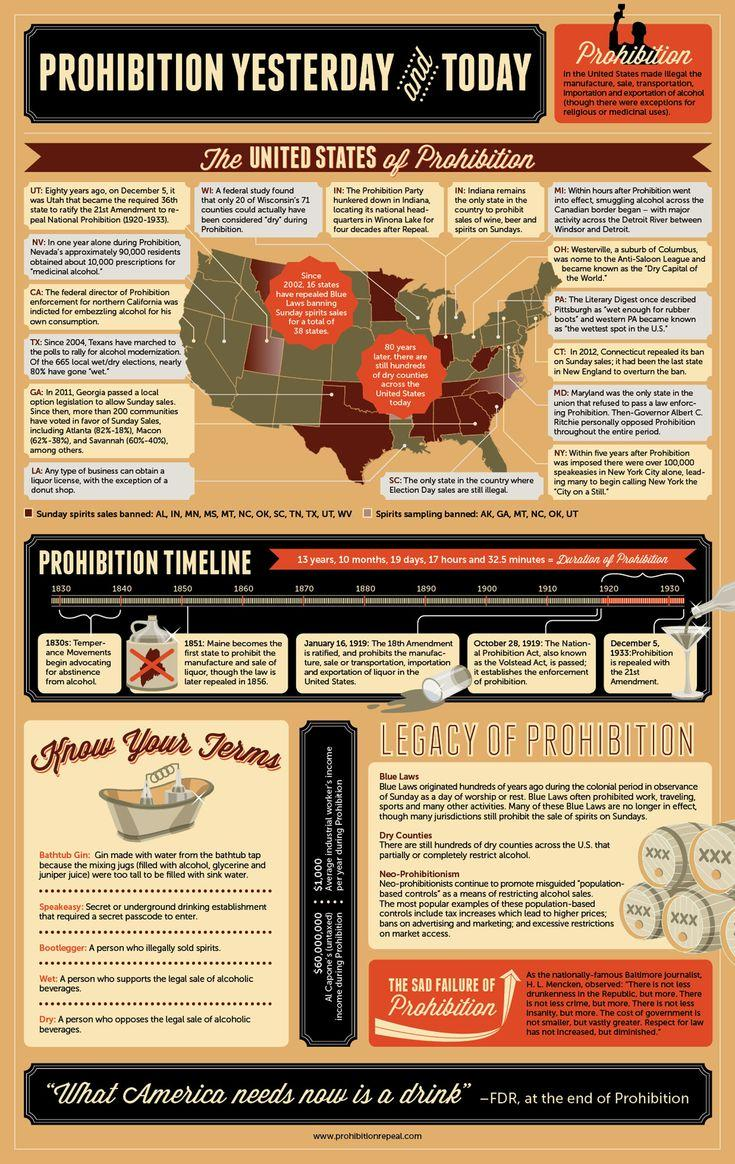List a handful of essential elements in this visual. In 1851, Maine banned the sale of liquor. The Temperance movement occurred during the time period of 1830-1840. Five states have banned the practice of spirits sampling. On December 5, 1933, the prohibition on liquor was revoked. The number of states that have banned the sale of alcohol on Sundays is 12. 